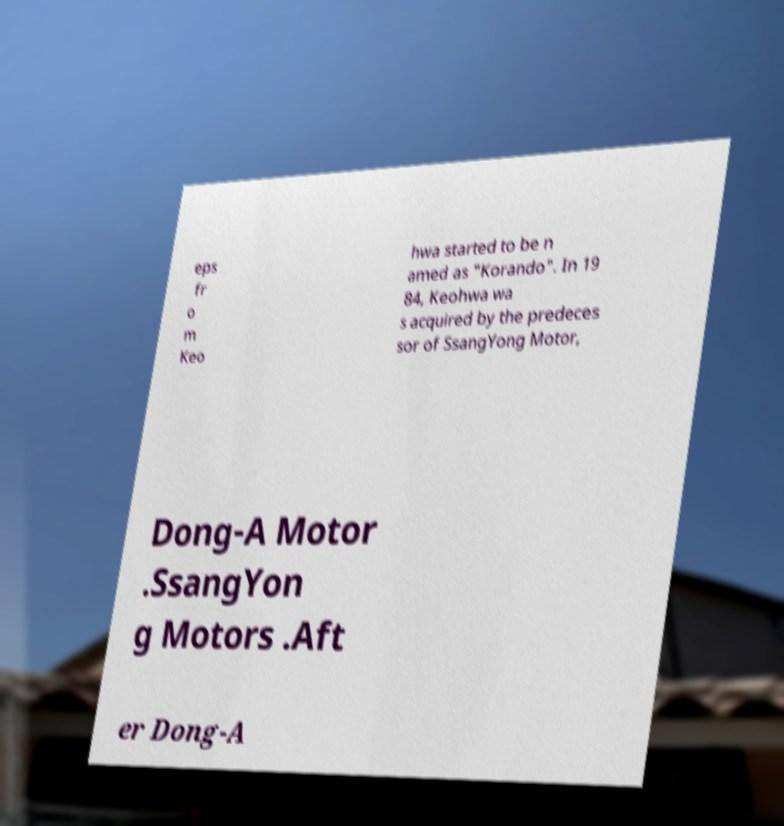Can you read and provide the text displayed in the image?This photo seems to have some interesting text. Can you extract and type it out for me? eps fr o m Keo hwa started to be n amed as "Korando". In 19 84, Keohwa wa s acquired by the predeces sor of SsangYong Motor, Dong-A Motor .SsangYon g Motors .Aft er Dong-A 